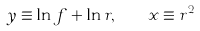<formula> <loc_0><loc_0><loc_500><loc_500>y \equiv \ln f + \ln r , \quad x \equiv r ^ { 2 }</formula> 